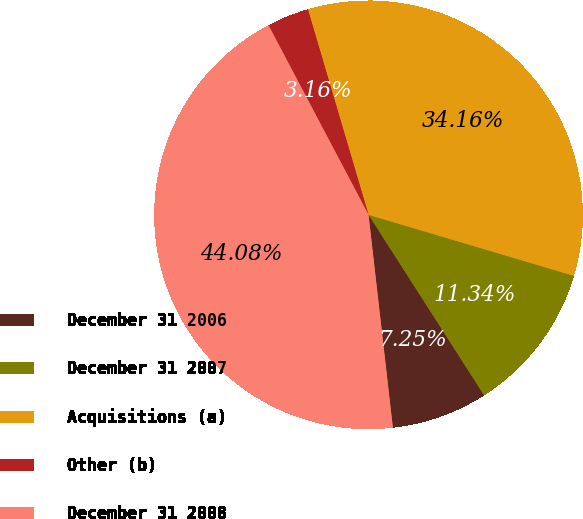Convert chart. <chart><loc_0><loc_0><loc_500><loc_500><pie_chart><fcel>December 31 2006<fcel>December 31 2007<fcel>Acquisitions (a)<fcel>Other (b)<fcel>December 31 2008<nl><fcel>7.25%<fcel>11.34%<fcel>34.16%<fcel>3.16%<fcel>44.08%<nl></chart> 